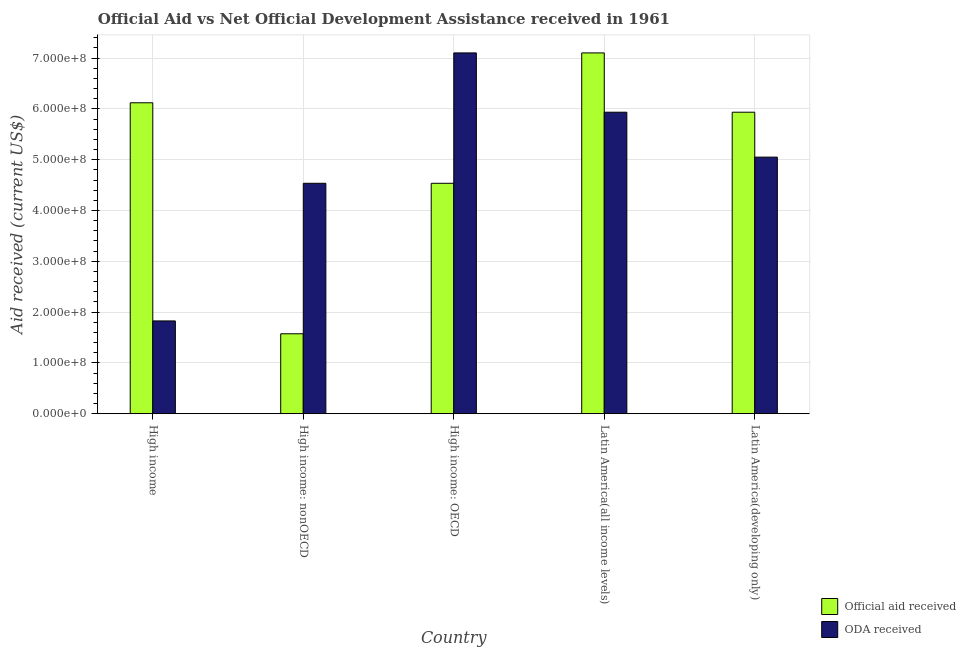How many different coloured bars are there?
Provide a short and direct response. 2. How many groups of bars are there?
Make the answer very short. 5. How many bars are there on the 5th tick from the left?
Provide a short and direct response. 2. What is the label of the 4th group of bars from the left?
Give a very brief answer. Latin America(all income levels). What is the official aid received in High income: OECD?
Give a very brief answer. 4.54e+08. Across all countries, what is the maximum official aid received?
Give a very brief answer. 7.10e+08. Across all countries, what is the minimum oda received?
Your answer should be very brief. 1.83e+08. In which country was the official aid received maximum?
Provide a short and direct response. Latin America(all income levels). In which country was the official aid received minimum?
Ensure brevity in your answer.  High income: nonOECD. What is the total official aid received in the graph?
Ensure brevity in your answer.  2.53e+09. What is the difference between the official aid received in High income: OECD and that in Latin America(developing only)?
Offer a terse response. -1.40e+08. What is the difference between the official aid received in High income: OECD and the oda received in Latin America(developing only)?
Offer a terse response. -5.15e+07. What is the average official aid received per country?
Offer a terse response. 5.05e+08. What is the difference between the official aid received and oda received in Latin America(all income levels)?
Your response must be concise. 1.17e+08. In how many countries, is the oda received greater than 380000000 US$?
Ensure brevity in your answer.  4. What is the ratio of the oda received in High income: OECD to that in Latin America(developing only)?
Give a very brief answer. 1.41. Is the difference between the official aid received in High income and High income: OECD greater than the difference between the oda received in High income and High income: OECD?
Ensure brevity in your answer.  Yes. What is the difference between the highest and the second highest oda received?
Give a very brief answer. 1.17e+08. What is the difference between the highest and the lowest oda received?
Ensure brevity in your answer.  5.27e+08. In how many countries, is the official aid received greater than the average official aid received taken over all countries?
Give a very brief answer. 3. Is the sum of the official aid received in High income and Latin America(developing only) greater than the maximum oda received across all countries?
Make the answer very short. Yes. What does the 2nd bar from the left in High income: OECD represents?
Your response must be concise. ODA received. What does the 2nd bar from the right in Latin America(all income levels) represents?
Your answer should be compact. Official aid received. How many bars are there?
Make the answer very short. 10. Are all the bars in the graph horizontal?
Your answer should be compact. No. What is the difference between two consecutive major ticks on the Y-axis?
Offer a terse response. 1.00e+08. What is the title of the graph?
Provide a succinct answer. Official Aid vs Net Official Development Assistance received in 1961 . What is the label or title of the X-axis?
Your answer should be very brief. Country. What is the label or title of the Y-axis?
Your answer should be very brief. Aid received (current US$). What is the Aid received (current US$) in Official aid received in High income?
Provide a succinct answer. 6.12e+08. What is the Aid received (current US$) of ODA received in High income?
Offer a very short reply. 1.83e+08. What is the Aid received (current US$) in Official aid received in High income: nonOECD?
Your response must be concise. 1.57e+08. What is the Aid received (current US$) in ODA received in High income: nonOECD?
Provide a succinct answer. 4.54e+08. What is the Aid received (current US$) in Official aid received in High income: OECD?
Offer a very short reply. 4.54e+08. What is the Aid received (current US$) of ODA received in High income: OECD?
Keep it short and to the point. 7.10e+08. What is the Aid received (current US$) of Official aid received in Latin America(all income levels)?
Your response must be concise. 7.10e+08. What is the Aid received (current US$) of ODA received in Latin America(all income levels)?
Your answer should be very brief. 5.93e+08. What is the Aid received (current US$) of Official aid received in Latin America(developing only)?
Your answer should be compact. 5.93e+08. What is the Aid received (current US$) in ODA received in Latin America(developing only)?
Offer a terse response. 5.05e+08. Across all countries, what is the maximum Aid received (current US$) of Official aid received?
Offer a very short reply. 7.10e+08. Across all countries, what is the maximum Aid received (current US$) in ODA received?
Offer a very short reply. 7.10e+08. Across all countries, what is the minimum Aid received (current US$) in Official aid received?
Provide a short and direct response. 1.57e+08. Across all countries, what is the minimum Aid received (current US$) in ODA received?
Your response must be concise. 1.83e+08. What is the total Aid received (current US$) of Official aid received in the graph?
Your response must be concise. 2.53e+09. What is the total Aid received (current US$) of ODA received in the graph?
Offer a very short reply. 2.44e+09. What is the difference between the Aid received (current US$) of Official aid received in High income and that in High income: nonOECD?
Provide a succinct answer. 4.55e+08. What is the difference between the Aid received (current US$) of ODA received in High income and that in High income: nonOECD?
Your response must be concise. -2.71e+08. What is the difference between the Aid received (current US$) of Official aid received in High income and that in High income: OECD?
Offer a very short reply. 1.58e+08. What is the difference between the Aid received (current US$) in ODA received in High income and that in High income: OECD?
Ensure brevity in your answer.  -5.27e+08. What is the difference between the Aid received (current US$) in Official aid received in High income and that in Latin America(all income levels)?
Offer a terse response. -9.81e+07. What is the difference between the Aid received (current US$) in ODA received in High income and that in Latin America(all income levels)?
Your answer should be compact. -4.11e+08. What is the difference between the Aid received (current US$) in Official aid received in High income and that in Latin America(developing only)?
Make the answer very short. 1.86e+07. What is the difference between the Aid received (current US$) of ODA received in High income and that in Latin America(developing only)?
Your response must be concise. -3.22e+08. What is the difference between the Aid received (current US$) of Official aid received in High income: nonOECD and that in High income: OECD?
Give a very brief answer. -2.96e+08. What is the difference between the Aid received (current US$) of ODA received in High income: nonOECD and that in High income: OECD?
Your response must be concise. -2.57e+08. What is the difference between the Aid received (current US$) of Official aid received in High income: nonOECD and that in Latin America(all income levels)?
Offer a terse response. -5.53e+08. What is the difference between the Aid received (current US$) of ODA received in High income: nonOECD and that in Latin America(all income levels)?
Your answer should be compact. -1.40e+08. What is the difference between the Aid received (current US$) of Official aid received in High income: nonOECD and that in Latin America(developing only)?
Provide a succinct answer. -4.36e+08. What is the difference between the Aid received (current US$) in ODA received in High income: nonOECD and that in Latin America(developing only)?
Provide a short and direct response. -5.15e+07. What is the difference between the Aid received (current US$) of Official aid received in High income: OECD and that in Latin America(all income levels)?
Make the answer very short. -2.57e+08. What is the difference between the Aid received (current US$) in ODA received in High income: OECD and that in Latin America(all income levels)?
Your answer should be compact. 1.17e+08. What is the difference between the Aid received (current US$) in Official aid received in High income: OECD and that in Latin America(developing only)?
Your answer should be compact. -1.40e+08. What is the difference between the Aid received (current US$) of ODA received in High income: OECD and that in Latin America(developing only)?
Provide a succinct answer. 2.05e+08. What is the difference between the Aid received (current US$) of Official aid received in Latin America(all income levels) and that in Latin America(developing only)?
Make the answer very short. 1.17e+08. What is the difference between the Aid received (current US$) in ODA received in Latin America(all income levels) and that in Latin America(developing only)?
Provide a short and direct response. 8.84e+07. What is the difference between the Aid received (current US$) in Official aid received in High income and the Aid received (current US$) in ODA received in High income: nonOECD?
Offer a terse response. 1.58e+08. What is the difference between the Aid received (current US$) in Official aid received in High income and the Aid received (current US$) in ODA received in High income: OECD?
Keep it short and to the point. -9.81e+07. What is the difference between the Aid received (current US$) in Official aid received in High income and the Aid received (current US$) in ODA received in Latin America(all income levels)?
Provide a short and direct response. 1.86e+07. What is the difference between the Aid received (current US$) in Official aid received in High income and the Aid received (current US$) in ODA received in Latin America(developing only)?
Provide a succinct answer. 1.07e+08. What is the difference between the Aid received (current US$) in Official aid received in High income: nonOECD and the Aid received (current US$) in ODA received in High income: OECD?
Offer a terse response. -5.53e+08. What is the difference between the Aid received (current US$) of Official aid received in High income: nonOECD and the Aid received (current US$) of ODA received in Latin America(all income levels)?
Make the answer very short. -4.36e+08. What is the difference between the Aid received (current US$) of Official aid received in High income: nonOECD and the Aid received (current US$) of ODA received in Latin America(developing only)?
Make the answer very short. -3.48e+08. What is the difference between the Aid received (current US$) of Official aid received in High income: OECD and the Aid received (current US$) of ODA received in Latin America(all income levels)?
Provide a succinct answer. -1.40e+08. What is the difference between the Aid received (current US$) in Official aid received in High income: OECD and the Aid received (current US$) in ODA received in Latin America(developing only)?
Your answer should be compact. -5.15e+07. What is the difference between the Aid received (current US$) in Official aid received in Latin America(all income levels) and the Aid received (current US$) in ODA received in Latin America(developing only)?
Offer a very short reply. 2.05e+08. What is the average Aid received (current US$) in Official aid received per country?
Your answer should be very brief. 5.05e+08. What is the average Aid received (current US$) of ODA received per country?
Your answer should be compact. 4.89e+08. What is the difference between the Aid received (current US$) in Official aid received and Aid received (current US$) in ODA received in High income?
Your response must be concise. 4.29e+08. What is the difference between the Aid received (current US$) of Official aid received and Aid received (current US$) of ODA received in High income: nonOECD?
Provide a short and direct response. -2.96e+08. What is the difference between the Aid received (current US$) in Official aid received and Aid received (current US$) in ODA received in High income: OECD?
Give a very brief answer. -2.57e+08. What is the difference between the Aid received (current US$) of Official aid received and Aid received (current US$) of ODA received in Latin America(all income levels)?
Make the answer very short. 1.17e+08. What is the difference between the Aid received (current US$) in Official aid received and Aid received (current US$) in ODA received in Latin America(developing only)?
Keep it short and to the point. 8.84e+07. What is the ratio of the Aid received (current US$) of Official aid received in High income to that in High income: nonOECD?
Your response must be concise. 3.89. What is the ratio of the Aid received (current US$) in ODA received in High income to that in High income: nonOECD?
Keep it short and to the point. 0.4. What is the ratio of the Aid received (current US$) of Official aid received in High income to that in High income: OECD?
Offer a very short reply. 1.35. What is the ratio of the Aid received (current US$) of ODA received in High income to that in High income: OECD?
Provide a succinct answer. 0.26. What is the ratio of the Aid received (current US$) of Official aid received in High income to that in Latin America(all income levels)?
Offer a terse response. 0.86. What is the ratio of the Aid received (current US$) in ODA received in High income to that in Latin America(all income levels)?
Your answer should be very brief. 0.31. What is the ratio of the Aid received (current US$) in Official aid received in High income to that in Latin America(developing only)?
Your answer should be compact. 1.03. What is the ratio of the Aid received (current US$) in ODA received in High income to that in Latin America(developing only)?
Your answer should be very brief. 0.36. What is the ratio of the Aid received (current US$) of Official aid received in High income: nonOECD to that in High income: OECD?
Make the answer very short. 0.35. What is the ratio of the Aid received (current US$) in ODA received in High income: nonOECD to that in High income: OECD?
Your answer should be compact. 0.64. What is the ratio of the Aid received (current US$) in Official aid received in High income: nonOECD to that in Latin America(all income levels)?
Your response must be concise. 0.22. What is the ratio of the Aid received (current US$) in ODA received in High income: nonOECD to that in Latin America(all income levels)?
Your response must be concise. 0.76. What is the ratio of the Aid received (current US$) of Official aid received in High income: nonOECD to that in Latin America(developing only)?
Offer a very short reply. 0.27. What is the ratio of the Aid received (current US$) in ODA received in High income: nonOECD to that in Latin America(developing only)?
Ensure brevity in your answer.  0.9. What is the ratio of the Aid received (current US$) in Official aid received in High income: OECD to that in Latin America(all income levels)?
Offer a very short reply. 0.64. What is the ratio of the Aid received (current US$) in ODA received in High income: OECD to that in Latin America(all income levels)?
Offer a very short reply. 1.2. What is the ratio of the Aid received (current US$) of Official aid received in High income: OECD to that in Latin America(developing only)?
Offer a very short reply. 0.76. What is the ratio of the Aid received (current US$) in ODA received in High income: OECD to that in Latin America(developing only)?
Your answer should be very brief. 1.41. What is the ratio of the Aid received (current US$) of Official aid received in Latin America(all income levels) to that in Latin America(developing only)?
Offer a terse response. 1.2. What is the ratio of the Aid received (current US$) in ODA received in Latin America(all income levels) to that in Latin America(developing only)?
Provide a short and direct response. 1.18. What is the difference between the highest and the second highest Aid received (current US$) in Official aid received?
Keep it short and to the point. 9.81e+07. What is the difference between the highest and the second highest Aid received (current US$) in ODA received?
Your response must be concise. 1.17e+08. What is the difference between the highest and the lowest Aid received (current US$) of Official aid received?
Provide a short and direct response. 5.53e+08. What is the difference between the highest and the lowest Aid received (current US$) in ODA received?
Your response must be concise. 5.27e+08. 